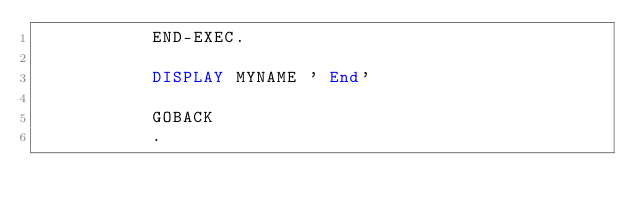Convert code to text. <code><loc_0><loc_0><loc_500><loc_500><_COBOL_>           END-EXEC.

           DISPLAY MYNAME ' End'
           
           GOBACK
           .


</code> 